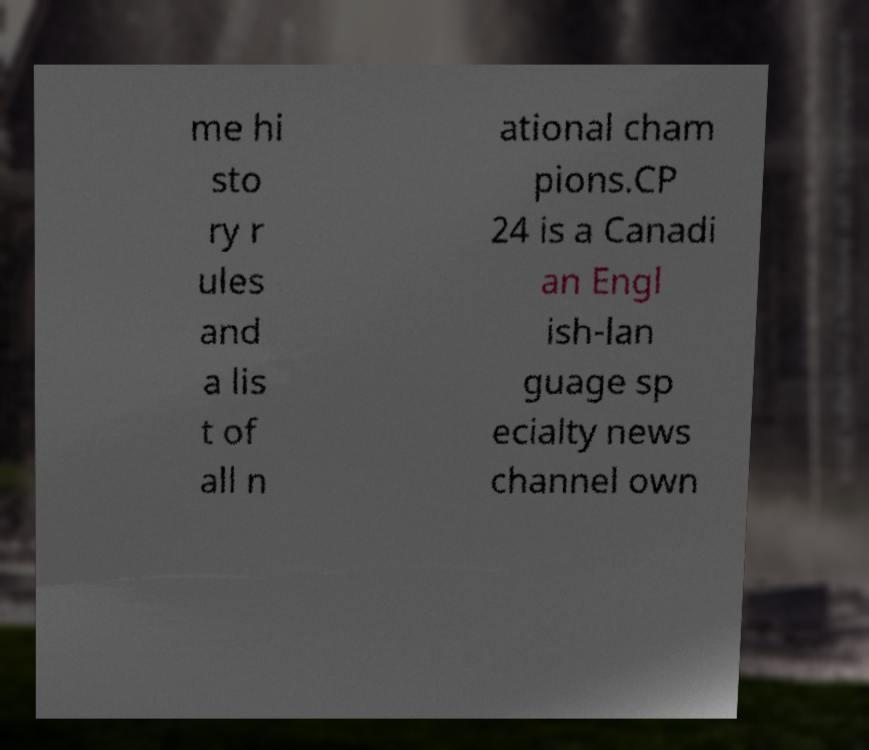Could you extract and type out the text from this image? me hi sto ry r ules and a lis t of all n ational cham pions.CP 24 is a Canadi an Engl ish-lan guage sp ecialty news channel own 